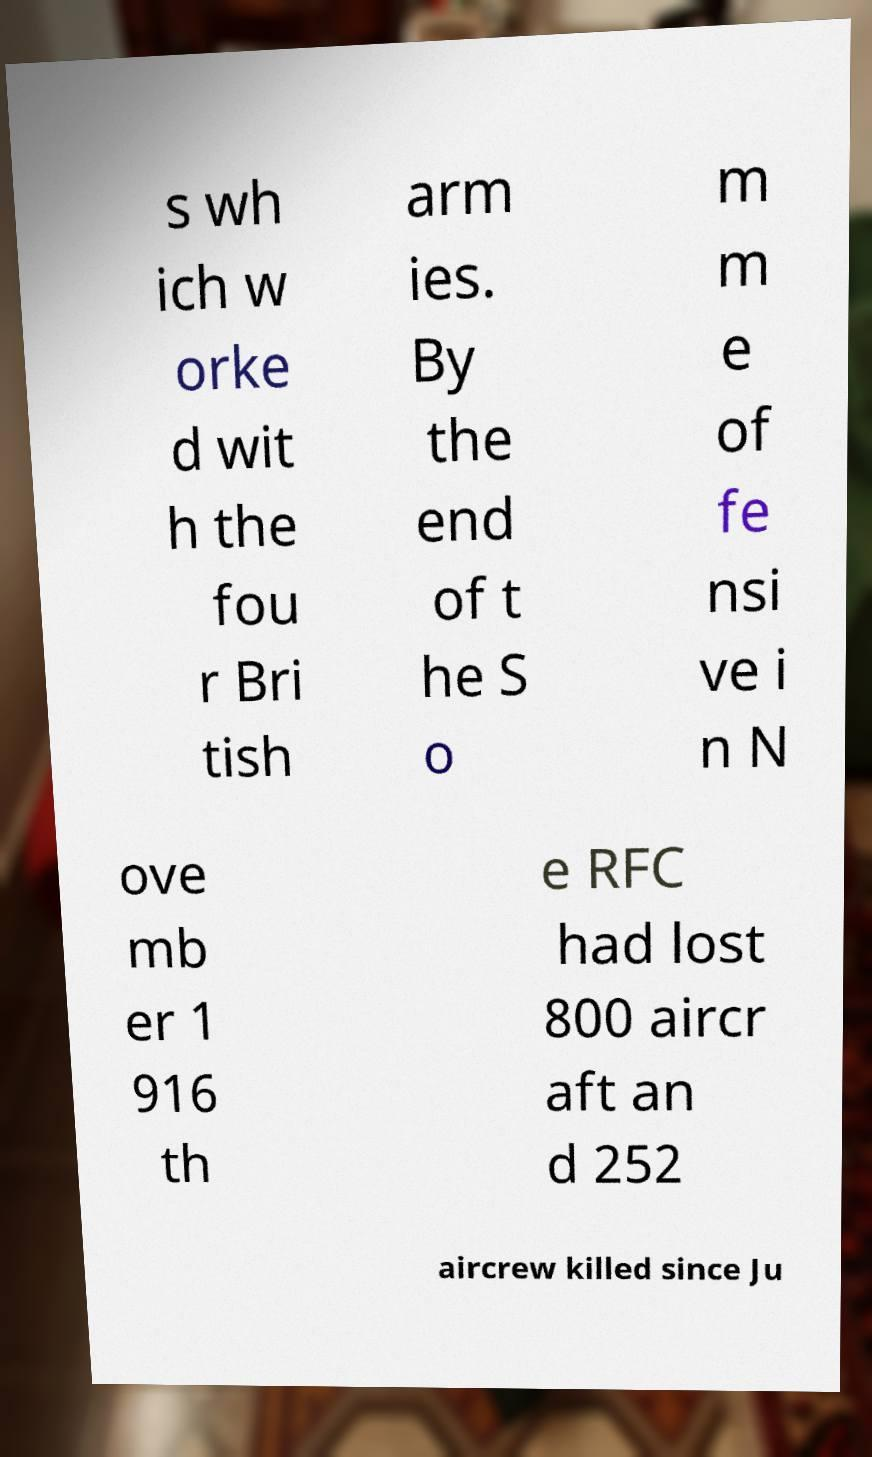There's text embedded in this image that I need extracted. Can you transcribe it verbatim? s wh ich w orke d wit h the fou r Bri tish arm ies. By the end of t he S o m m e of fe nsi ve i n N ove mb er 1 916 th e RFC had lost 800 aircr aft an d 252 aircrew killed since Ju 